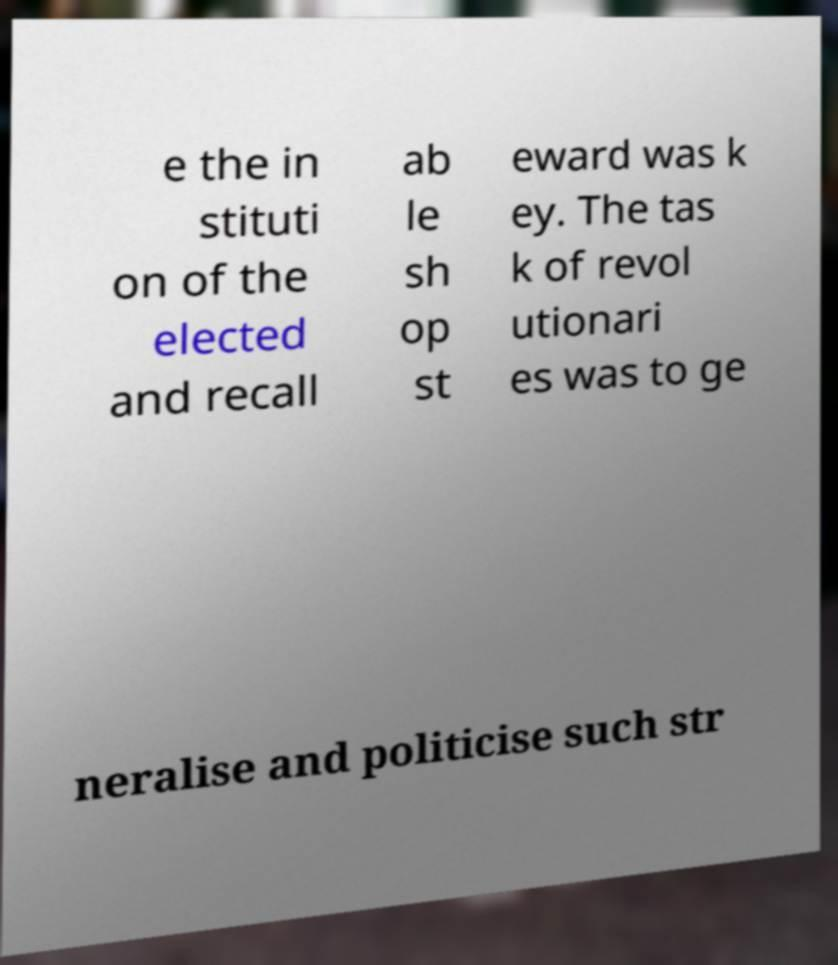For documentation purposes, I need the text within this image transcribed. Could you provide that? e the in stituti on of the elected and recall ab le sh op st eward was k ey. The tas k of revol utionari es was to ge neralise and politicise such str 